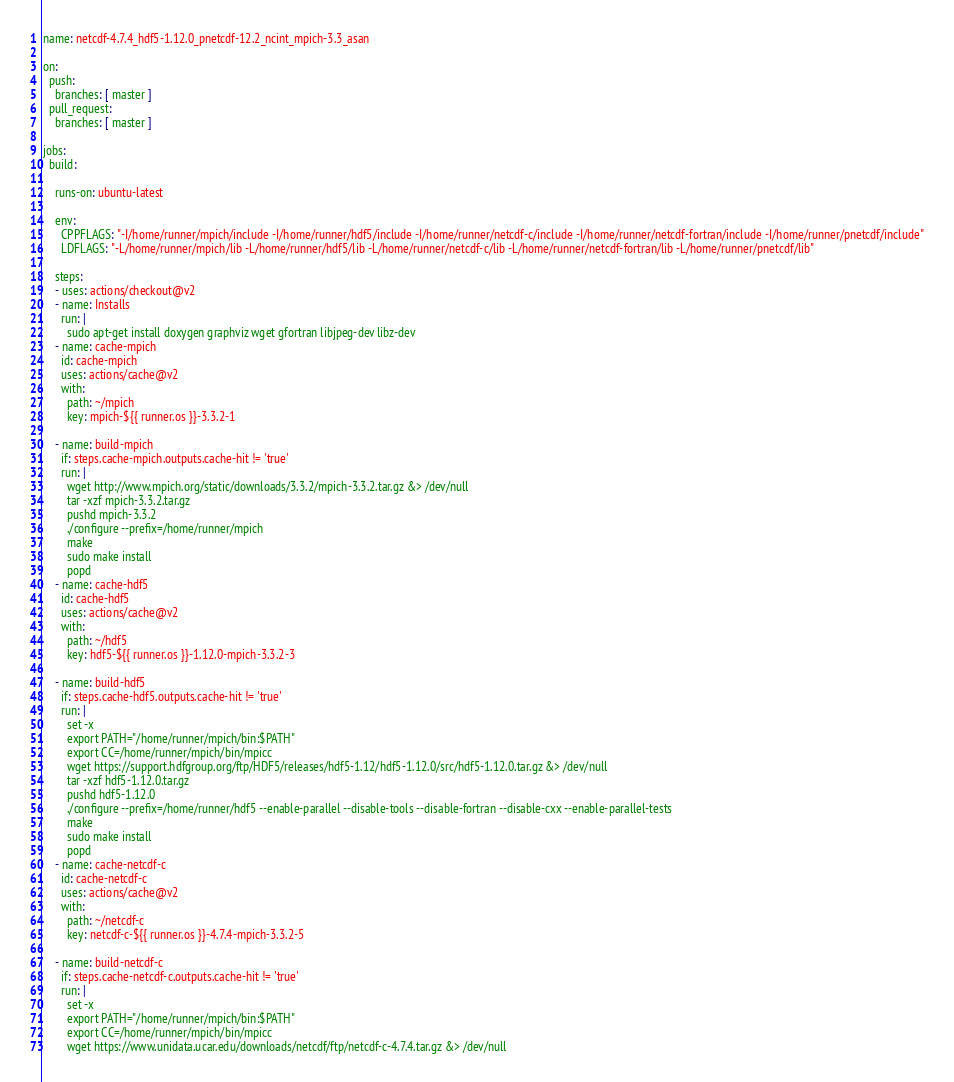Convert code to text. <code><loc_0><loc_0><loc_500><loc_500><_YAML_>name: netcdf-4.7.4_hdf5-1.12.0_pnetcdf-12.2_ncint_mpich-3.3_asan

on:
  push:
    branches: [ master ]
  pull_request:
    branches: [ master ]

jobs:
  build:

    runs-on: ubuntu-latest

    env:
      CPPFLAGS: "-I/home/runner/mpich/include -I/home/runner/hdf5/include -I/home/runner/netcdf-c/include -I/home/runner/netcdf-fortran/include -I/home/runner/pnetcdf/include"
      LDFLAGS: "-L/home/runner/mpich/lib -L/home/runner/hdf5/lib -L/home/runner/netcdf-c/lib -L/home/runner/netcdf-fortran/lib -L/home/runner/pnetcdf/lib"

    steps:
    - uses: actions/checkout@v2
    - name: Installs
      run: |
        sudo apt-get install doxygen graphviz wget gfortran libjpeg-dev libz-dev
    - name: cache-mpich
      id: cache-mpich
      uses: actions/cache@v2
      with:
        path: ~/mpich
        key: mpich-${{ runner.os }}-3.3.2-1

    - name: build-mpich
      if: steps.cache-mpich.outputs.cache-hit != 'true'
      run: |
        wget http://www.mpich.org/static/downloads/3.3.2/mpich-3.3.2.tar.gz &> /dev/null
        tar -xzf mpich-3.3.2.tar.gz
        pushd mpich-3.3.2
        ./configure --prefix=/home/runner/mpich
        make
        sudo make install
        popd
    - name: cache-hdf5
      id: cache-hdf5
      uses: actions/cache@v2
      with:
        path: ~/hdf5
        key: hdf5-${{ runner.os }}-1.12.0-mpich-3.3.2-3

    - name: build-hdf5
      if: steps.cache-hdf5.outputs.cache-hit != 'true'
      run: |
        set -x
        export PATH="/home/runner/mpich/bin:$PATH"
        export CC=/home/runner/mpich/bin/mpicc
        wget https://support.hdfgroup.org/ftp/HDF5/releases/hdf5-1.12/hdf5-1.12.0/src/hdf5-1.12.0.tar.gz &> /dev/null
        tar -xzf hdf5-1.12.0.tar.gz
        pushd hdf5-1.12.0
        ./configure --prefix=/home/runner/hdf5 --enable-parallel --disable-tools --disable-fortran --disable-cxx --enable-parallel-tests
        make
        sudo make install
        popd
    - name: cache-netcdf-c
      id: cache-netcdf-c
      uses: actions/cache@v2
      with:
        path: ~/netcdf-c
        key: netcdf-c-${{ runner.os }}-4.7.4-mpich-3.3.2-5

    - name: build-netcdf-c
      if: steps.cache-netcdf-c.outputs.cache-hit != 'true'
      run: |
        set -x
        export PATH="/home/runner/mpich/bin:$PATH"
        export CC=/home/runner/mpich/bin/mpicc
        wget https://www.unidata.ucar.edu/downloads/netcdf/ftp/netcdf-c-4.7.4.tar.gz &> /dev/null</code> 